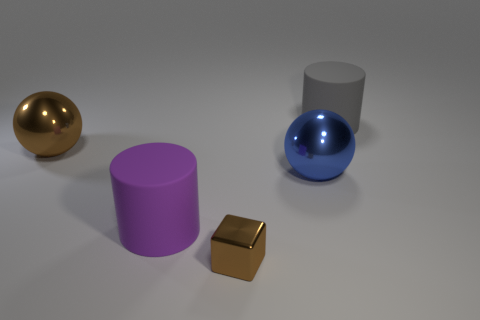Subtract all blue spheres. How many spheres are left? 1 Subtract 1 balls. How many balls are left? 1 Add 3 purple rubber cylinders. How many objects exist? 8 Subtract all blue shiny balls. Subtract all large cylinders. How many objects are left? 2 Add 2 matte objects. How many matte objects are left? 4 Add 5 large gray rubber things. How many large gray rubber things exist? 6 Subtract 0 yellow spheres. How many objects are left? 5 Subtract all cubes. How many objects are left? 4 Subtract all green blocks. Subtract all yellow cylinders. How many blocks are left? 1 Subtract all blue spheres. How many gray cylinders are left? 1 